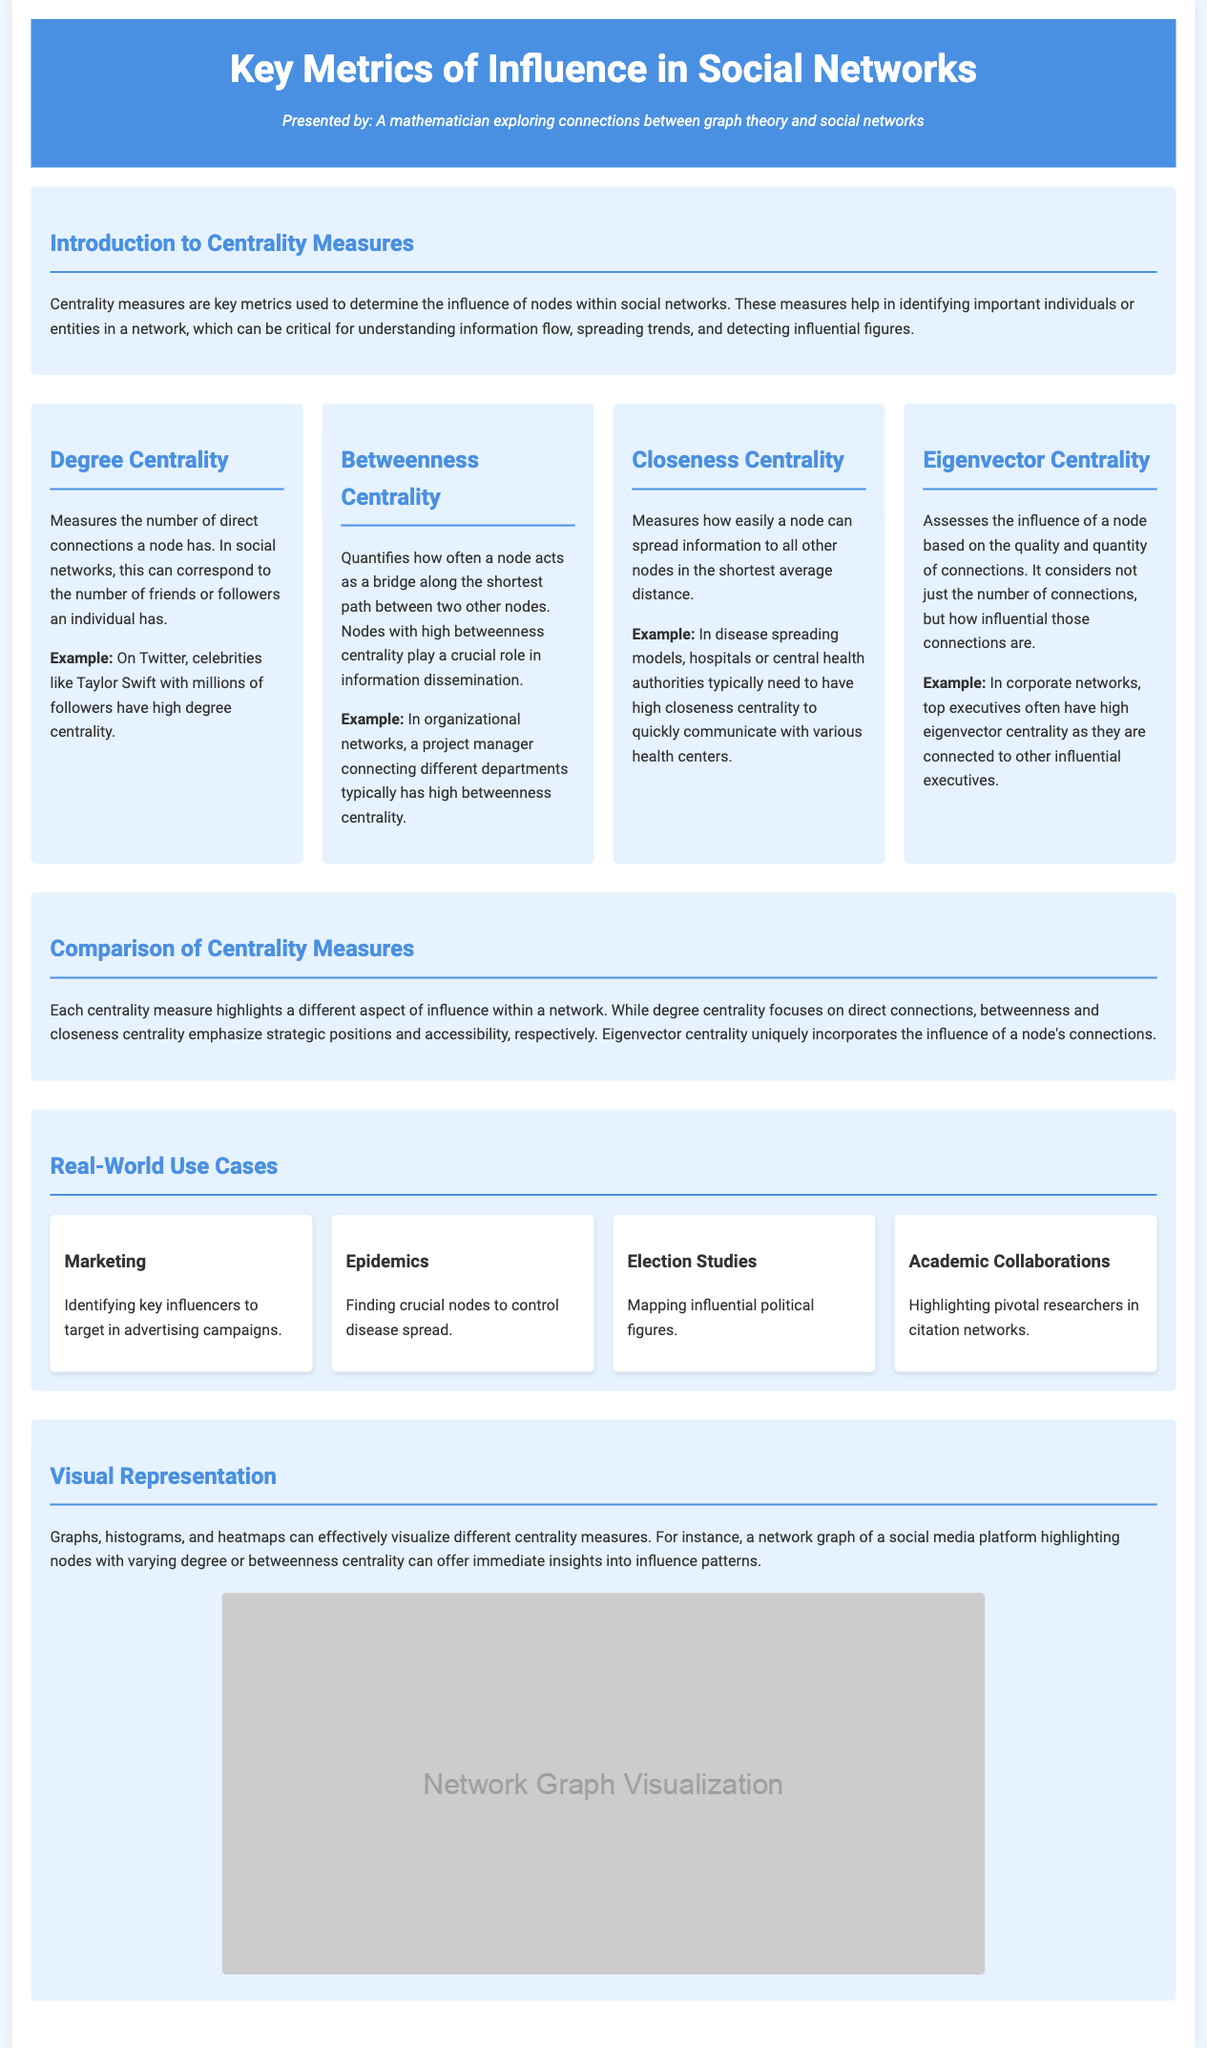What is the primary subject of the infographic? The primary subject is the key metrics of influence in social networks, particularly the comparison of centrality measures.
Answer: Centrality measures Who is the author of the infographic? The author of the infographic is a mathematician who explores connections between graph theory and social networks.
Answer: A mathematician What does Degree Centrality measure? Degree Centrality measures the number of direct connections a node has in a social network.
Answer: Direct connections Which centrality measure focuses on a node acting as a bridge? The centrality measure that focuses on a node acting as a bridge is Betweenness Centrality.
Answer: Betweenness Centrality What example illustrates Closeness Centrality in the document? The example that illustrates Closeness Centrality is hospitals or central health authorities.
Answer: Hospitals In what context is Eigenvector Centrality relevant? Eigenvector Centrality is relevant in corporate networks, particularly concerning top executives.
Answer: Corporate networks How many use cases are mentioned in the infographic? The infographic mentions four different use cases for centrality measures.
Answer: Four What type of visual representations are suggested for centrality measures? The suggested visual representations include graphs, histograms, and heatmaps.
Answer: Graphs, histograms, and heatmaps What is the color scheme used for the header of the infographic? The color scheme used for the header includes a background color of #4a90e2 and text in white.
Answer: #4a90e2 and white 